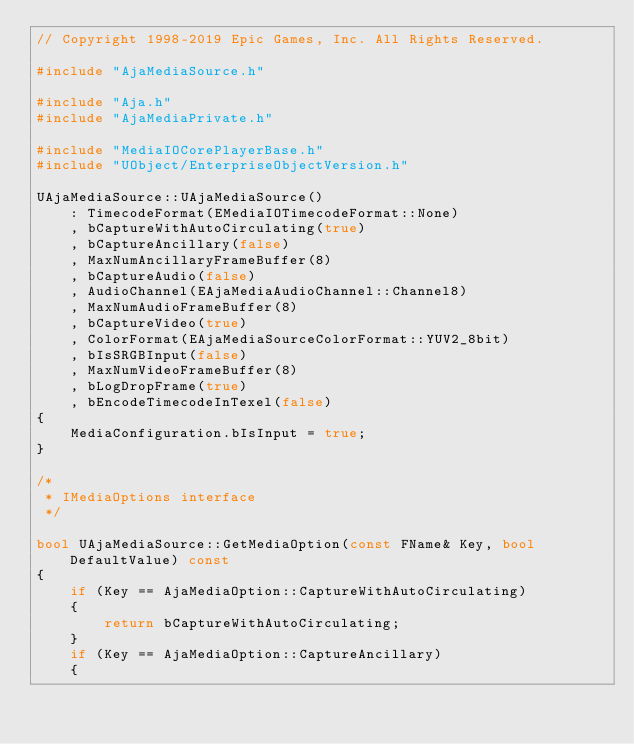<code> <loc_0><loc_0><loc_500><loc_500><_C++_>// Copyright 1998-2019 Epic Games, Inc. All Rights Reserved.

#include "AjaMediaSource.h"

#include "Aja.h"
#include "AjaMediaPrivate.h"

#include "MediaIOCorePlayerBase.h"
#include "UObject/EnterpriseObjectVersion.h"

UAjaMediaSource::UAjaMediaSource()
	: TimecodeFormat(EMediaIOTimecodeFormat::None)
	, bCaptureWithAutoCirculating(true)
	, bCaptureAncillary(false)
	, MaxNumAncillaryFrameBuffer(8)
	, bCaptureAudio(false)
	, AudioChannel(EAjaMediaAudioChannel::Channel8)
	, MaxNumAudioFrameBuffer(8)
	, bCaptureVideo(true)
	, ColorFormat(EAjaMediaSourceColorFormat::YUV2_8bit)
	, bIsSRGBInput(false)
	, MaxNumVideoFrameBuffer(8)
	, bLogDropFrame(true)
	, bEncodeTimecodeInTexel(false)
{
	MediaConfiguration.bIsInput = true;
}

/*
 * IMediaOptions interface
 */

bool UAjaMediaSource::GetMediaOption(const FName& Key, bool DefaultValue) const
{
	if (Key == AjaMediaOption::CaptureWithAutoCirculating)
	{
		return bCaptureWithAutoCirculating;
	}
	if (Key == AjaMediaOption::CaptureAncillary)
	{</code> 